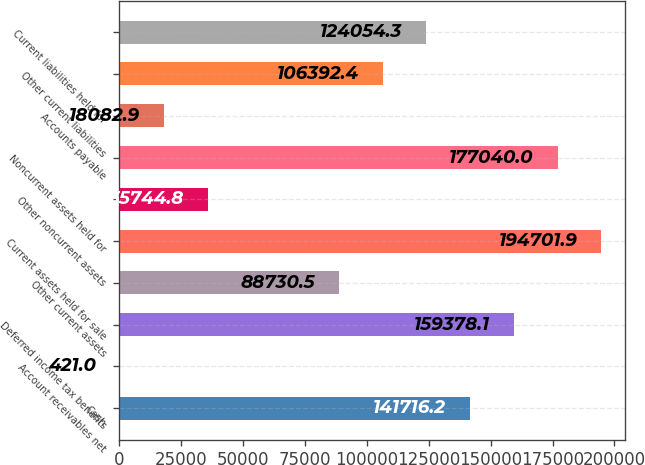Convert chart to OTSL. <chart><loc_0><loc_0><loc_500><loc_500><bar_chart><fcel>Cash<fcel>Account receivables net<fcel>Deferred income tax benefits<fcel>Other current assets<fcel>Current assets held for sale<fcel>Other noncurrent assets<fcel>Noncurrent assets held for<fcel>Accounts payable<fcel>Other current liabilities<fcel>Current liabilities held for<nl><fcel>141716<fcel>421<fcel>159378<fcel>88730.5<fcel>194702<fcel>35744.8<fcel>177040<fcel>18082.9<fcel>106392<fcel>124054<nl></chart> 